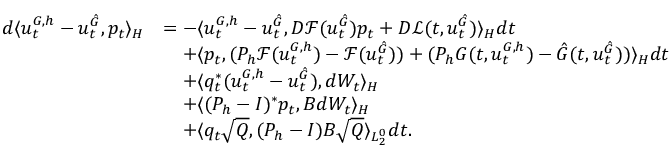<formula> <loc_0><loc_0><loc_500><loc_500>\begin{array} { r l } { d \langle u _ { t } ^ { G , h } - u _ { t } ^ { \hat { G } } , p _ { t } \rangle _ { H } } & { = - \langle u _ { t } ^ { G , h } - u _ { t } ^ { \hat { G } } , D \mathcal { F } ( u _ { t } ^ { \hat { G } } ) p _ { t } + D \mathcal { L } ( t , u _ { t } ^ { \hat { G } } ) \rangle _ { H } d t } \\ & { \quad + \langle p _ { t } , ( P _ { h } \mathcal { F } ( u _ { t } ^ { { G } , h } ) - \mathcal { F } ( u _ { t } ^ { \hat { G } } ) ) + ( P _ { h } G ( t , u _ { t } ^ { G , h } ) - \hat { G } ( t , u _ { t } ^ { \hat { G } } ) ) \rangle _ { H } d t } \\ & { \quad + \langle q _ { t } ^ { * } ( u _ { t } ^ { G , h } - u _ { t } ^ { \hat { G } } ) , d W _ { t } \rangle _ { H } } \\ & { \quad + \langle ( P _ { h } - I ) ^ { * } p _ { t } , B d W _ { t } \rangle _ { H } } \\ & { \quad + \langle q _ { t } \sqrt { Q } , ( P _ { h } - I ) B \sqrt { Q } \rangle _ { L _ { 2 } ^ { 0 } } d t . } \end{array}</formula> 